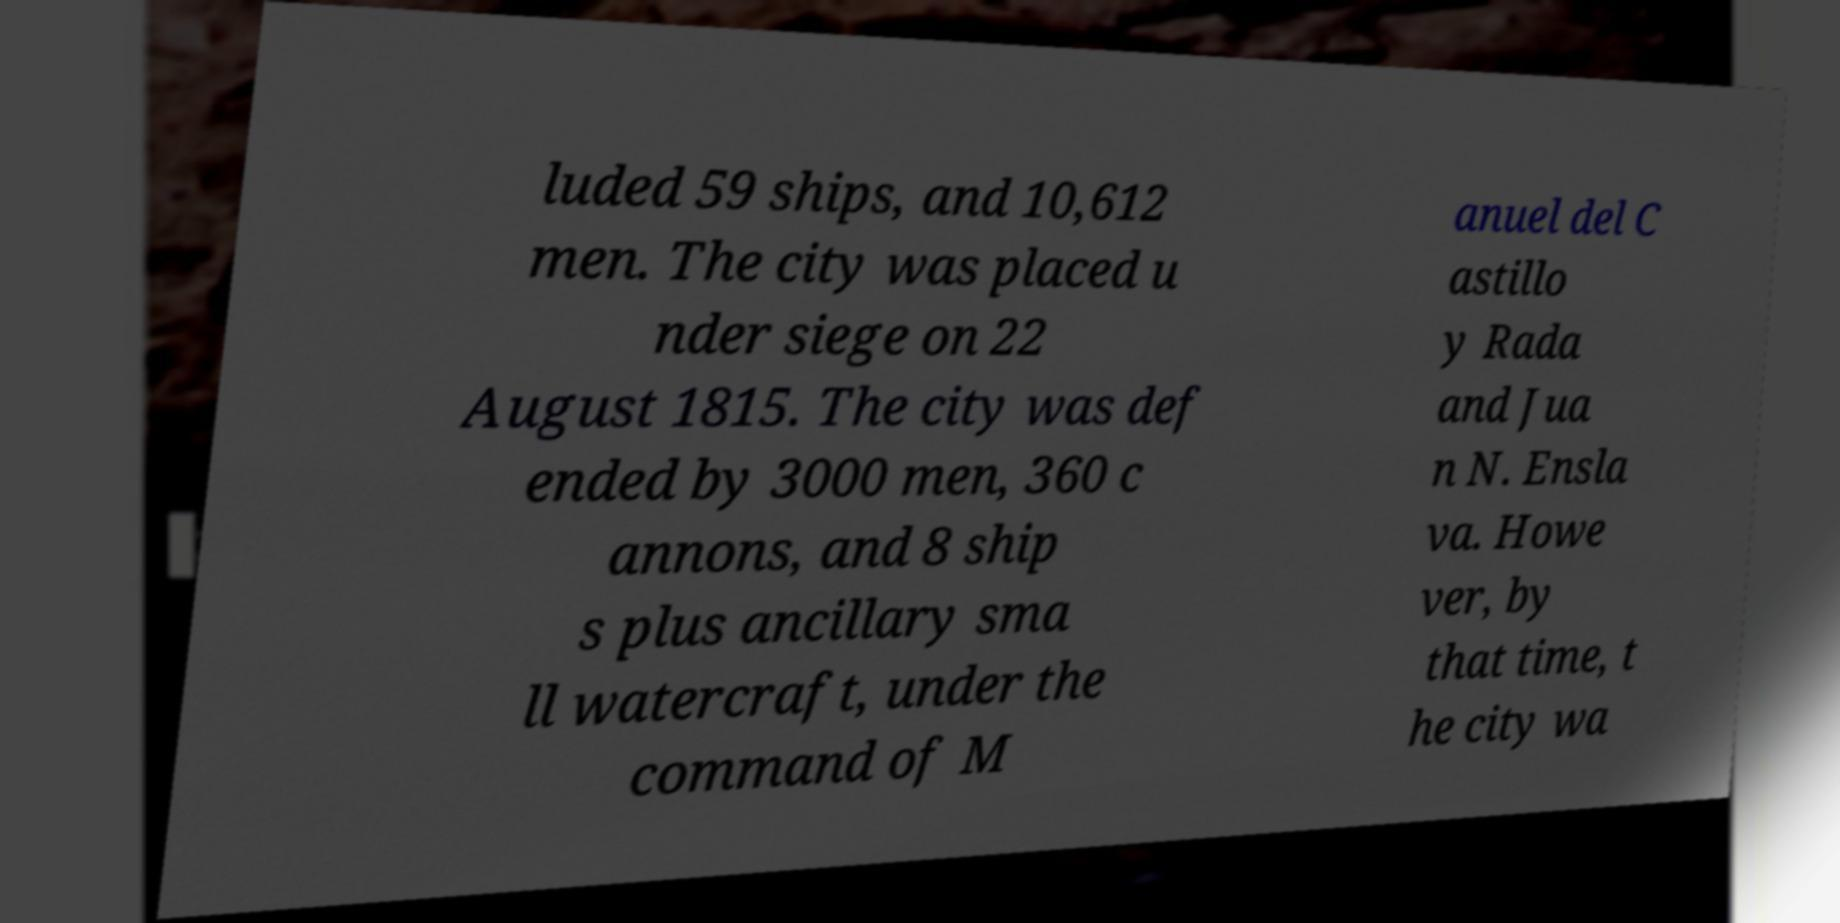I need the written content from this picture converted into text. Can you do that? luded 59 ships, and 10,612 men. The city was placed u nder siege on 22 August 1815. The city was def ended by 3000 men, 360 c annons, and 8 ship s plus ancillary sma ll watercraft, under the command of M anuel del C astillo y Rada and Jua n N. Ensla va. Howe ver, by that time, t he city wa 